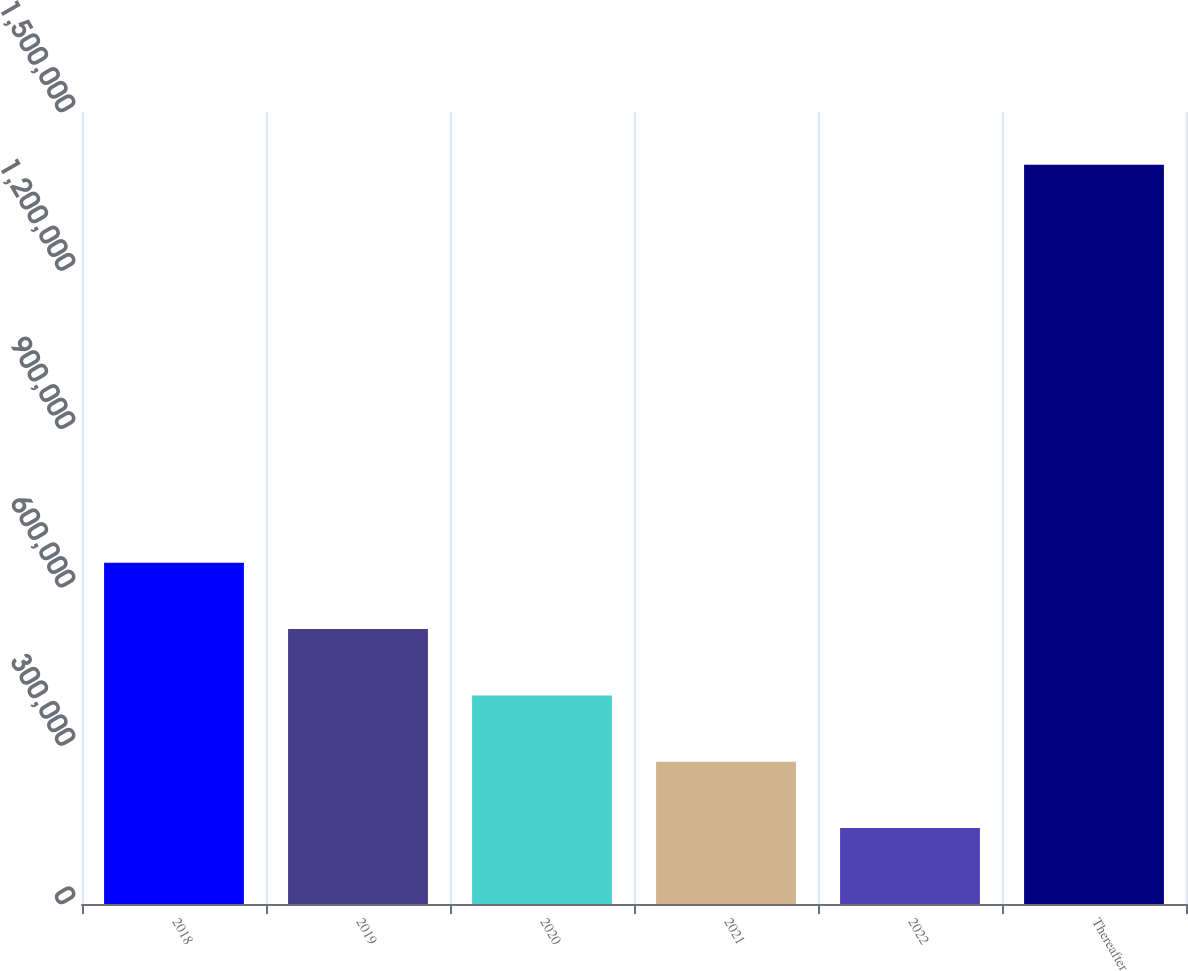<chart> <loc_0><loc_0><loc_500><loc_500><bar_chart><fcel>2018<fcel>2019<fcel>2020<fcel>2021<fcel>2022<fcel>Thereafter<nl><fcel>646374<fcel>520746<fcel>395118<fcel>269490<fcel>143862<fcel>1.40014e+06<nl></chart> 